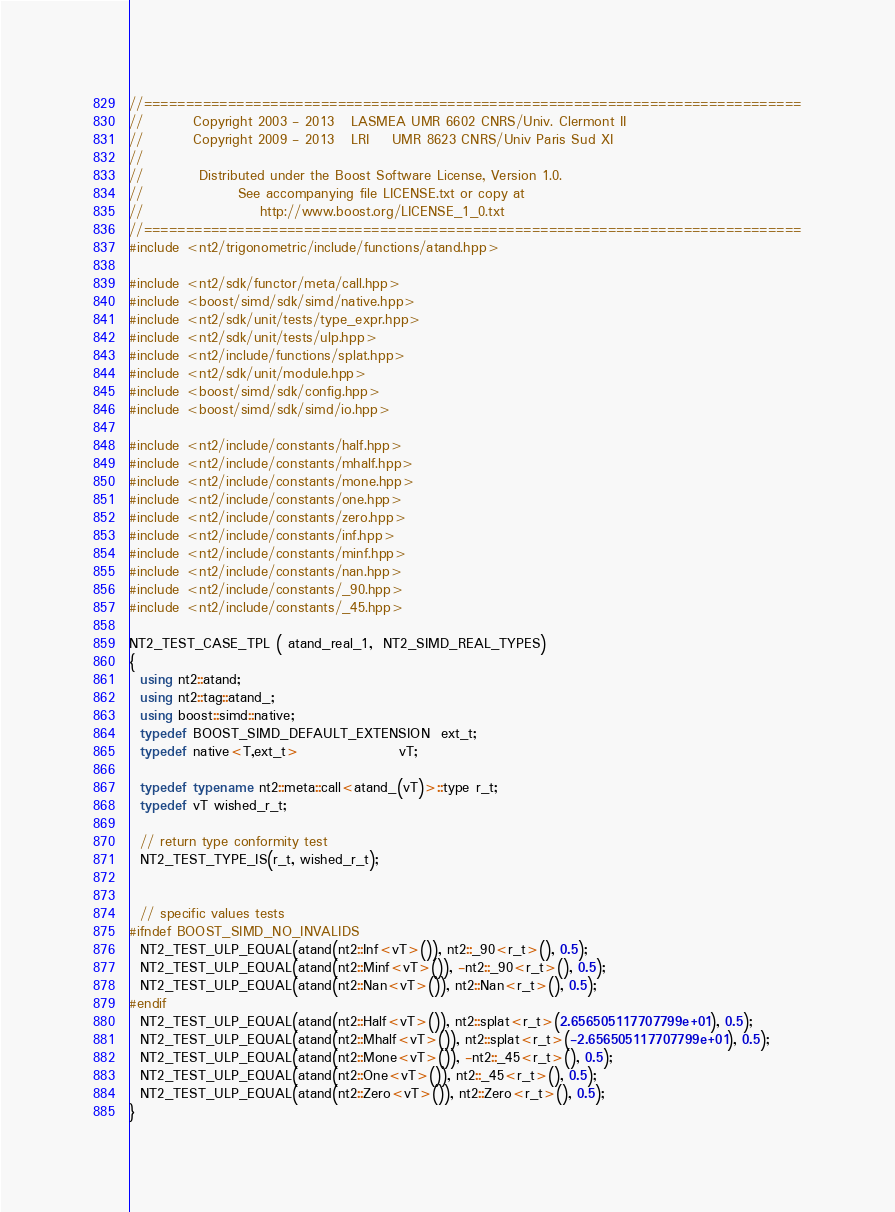<code> <loc_0><loc_0><loc_500><loc_500><_C++_>//==============================================================================
//         Copyright 2003 - 2013   LASMEA UMR 6602 CNRS/Univ. Clermont II
//         Copyright 2009 - 2013   LRI    UMR 8623 CNRS/Univ Paris Sud XI
//
//          Distributed under the Boost Software License, Version 1.0.
//                 See accompanying file LICENSE.txt or copy at
//                     http://www.boost.org/LICENSE_1_0.txt
//==============================================================================
#include <nt2/trigonometric/include/functions/atand.hpp>

#include <nt2/sdk/functor/meta/call.hpp>
#include <boost/simd/sdk/simd/native.hpp>
#include <nt2/sdk/unit/tests/type_expr.hpp>
#include <nt2/sdk/unit/tests/ulp.hpp>
#include <nt2/include/functions/splat.hpp>
#include <nt2/sdk/unit/module.hpp>
#include <boost/simd/sdk/config.hpp>
#include <boost/simd/sdk/simd/io.hpp>

#include <nt2/include/constants/half.hpp>
#include <nt2/include/constants/mhalf.hpp>
#include <nt2/include/constants/mone.hpp>
#include <nt2/include/constants/one.hpp>
#include <nt2/include/constants/zero.hpp>
#include <nt2/include/constants/inf.hpp>
#include <nt2/include/constants/minf.hpp>
#include <nt2/include/constants/nan.hpp>
#include <nt2/include/constants/_90.hpp>
#include <nt2/include/constants/_45.hpp>

NT2_TEST_CASE_TPL ( atand_real_1,  NT2_SIMD_REAL_TYPES)
{
  using nt2::atand;
  using nt2::tag::atand_;
  using boost::simd::native;
  typedef BOOST_SIMD_DEFAULT_EXTENSION  ext_t;
  typedef native<T,ext_t>                  vT;

  typedef typename nt2::meta::call<atand_(vT)>::type r_t;
  typedef vT wished_r_t;

  // return type conformity test
  NT2_TEST_TYPE_IS(r_t, wished_r_t);


  // specific values tests
#ifndef BOOST_SIMD_NO_INVALIDS
  NT2_TEST_ULP_EQUAL(atand(nt2::Inf<vT>()), nt2::_90<r_t>(), 0.5);
  NT2_TEST_ULP_EQUAL(atand(nt2::Minf<vT>()), -nt2::_90<r_t>(), 0.5);
  NT2_TEST_ULP_EQUAL(atand(nt2::Nan<vT>()), nt2::Nan<r_t>(), 0.5);
#endif
  NT2_TEST_ULP_EQUAL(atand(nt2::Half<vT>()), nt2::splat<r_t>(2.656505117707799e+01), 0.5);
  NT2_TEST_ULP_EQUAL(atand(nt2::Mhalf<vT>()), nt2::splat<r_t>(-2.656505117707799e+01), 0.5);
  NT2_TEST_ULP_EQUAL(atand(nt2::Mone<vT>()), -nt2::_45<r_t>(), 0.5);
  NT2_TEST_ULP_EQUAL(atand(nt2::One<vT>()), nt2::_45<r_t>(), 0.5);
  NT2_TEST_ULP_EQUAL(atand(nt2::Zero<vT>()), nt2::Zero<r_t>(), 0.5);
}
</code> 